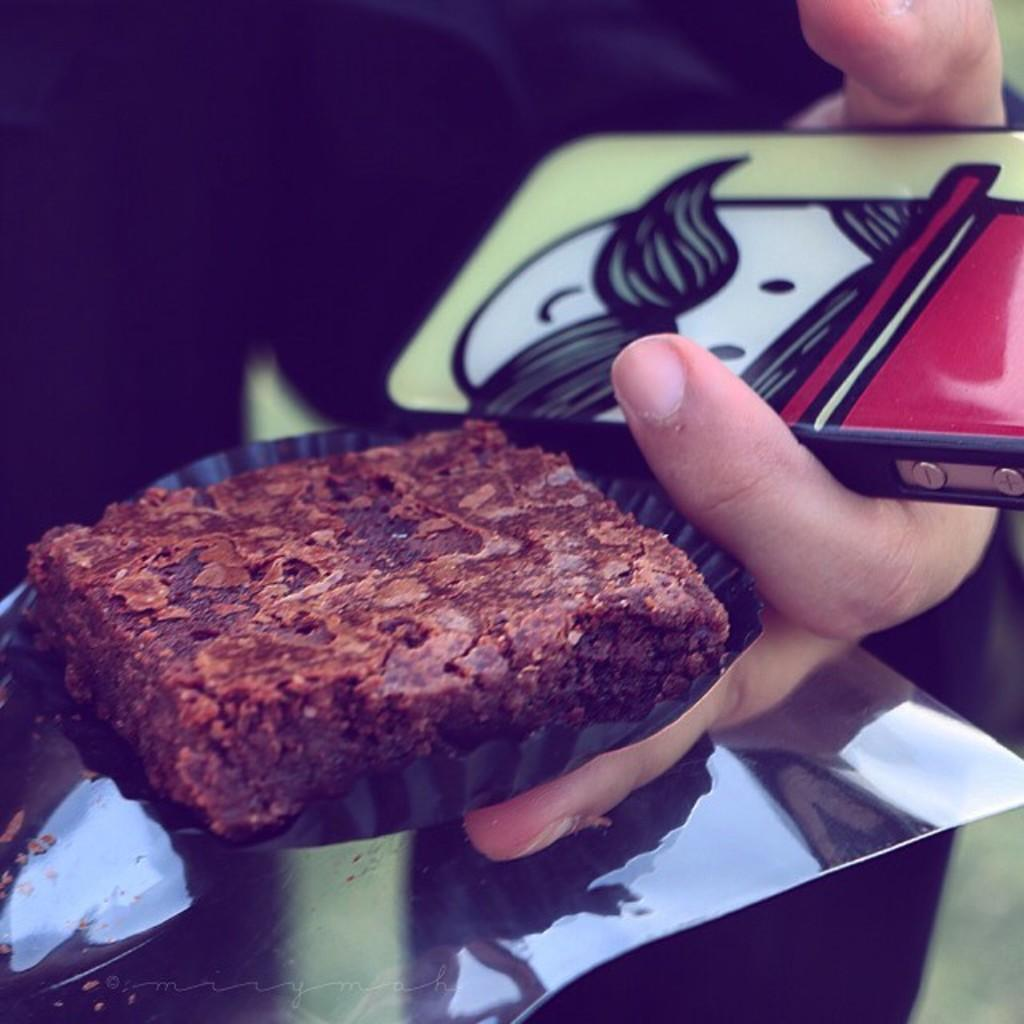What is the main subject of the image? There is a food item in the image. What else can be seen in the image besides the food item? There is a mobile and other objects in a person's hand in the image. How would you describe the background of the image? The background of the image is blurred. What type of relation does the cake have with the person in the image? There is no cake present in the image, so it is not possible to determine any relation between a cake and the person. 